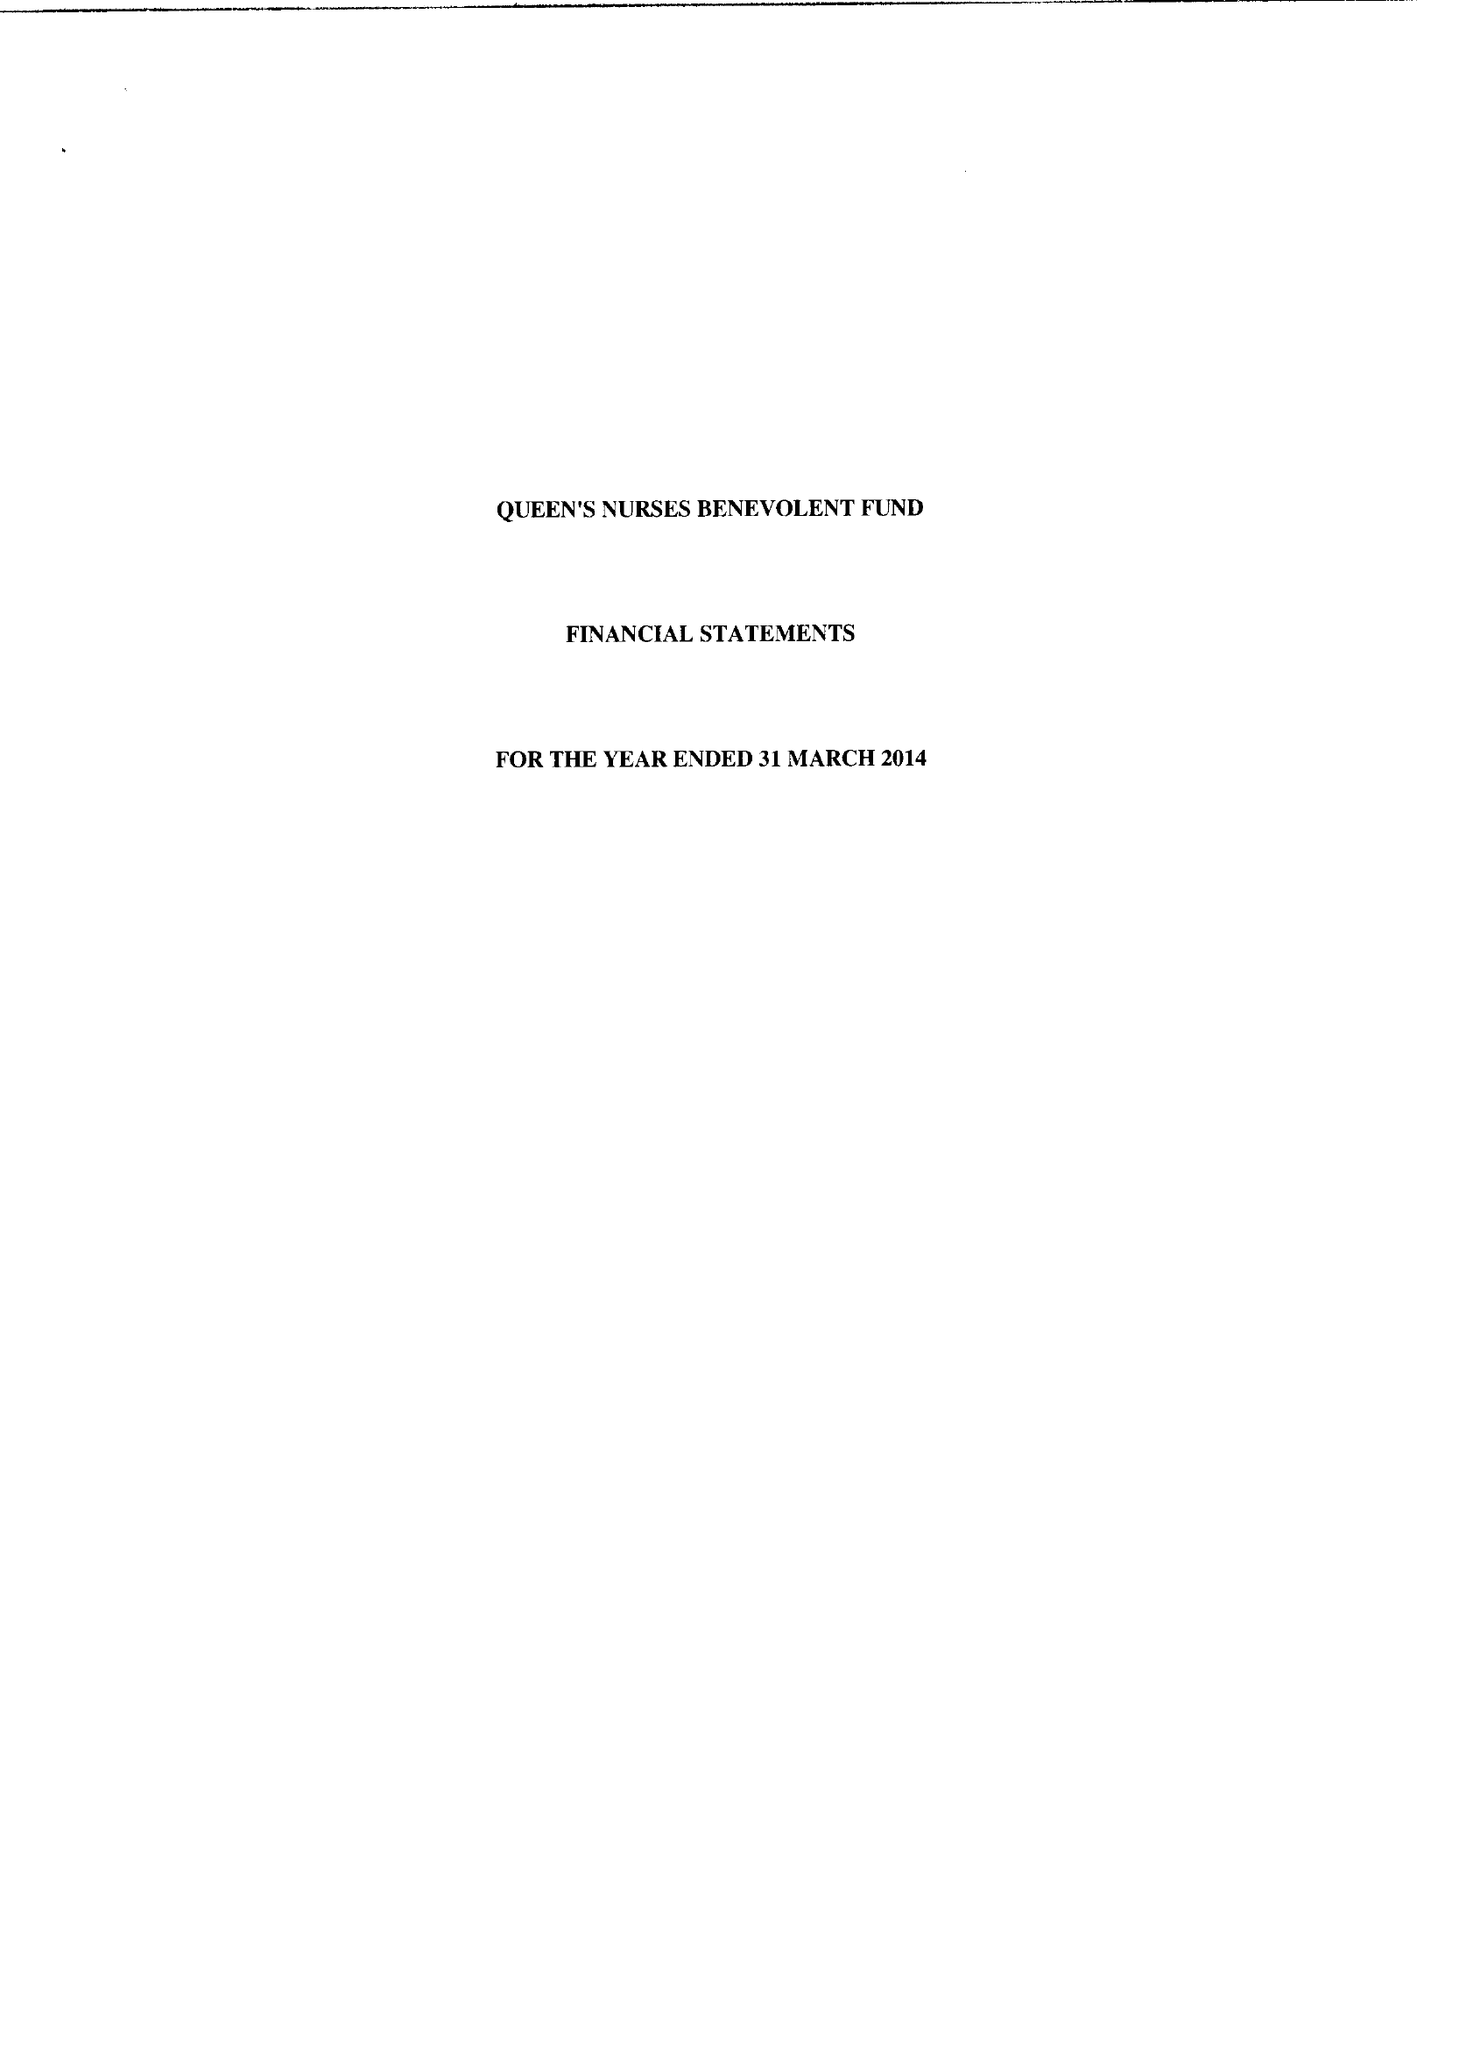What is the value for the address__postcode?
Answer the question using a single word or phrase. SM1 2DR 